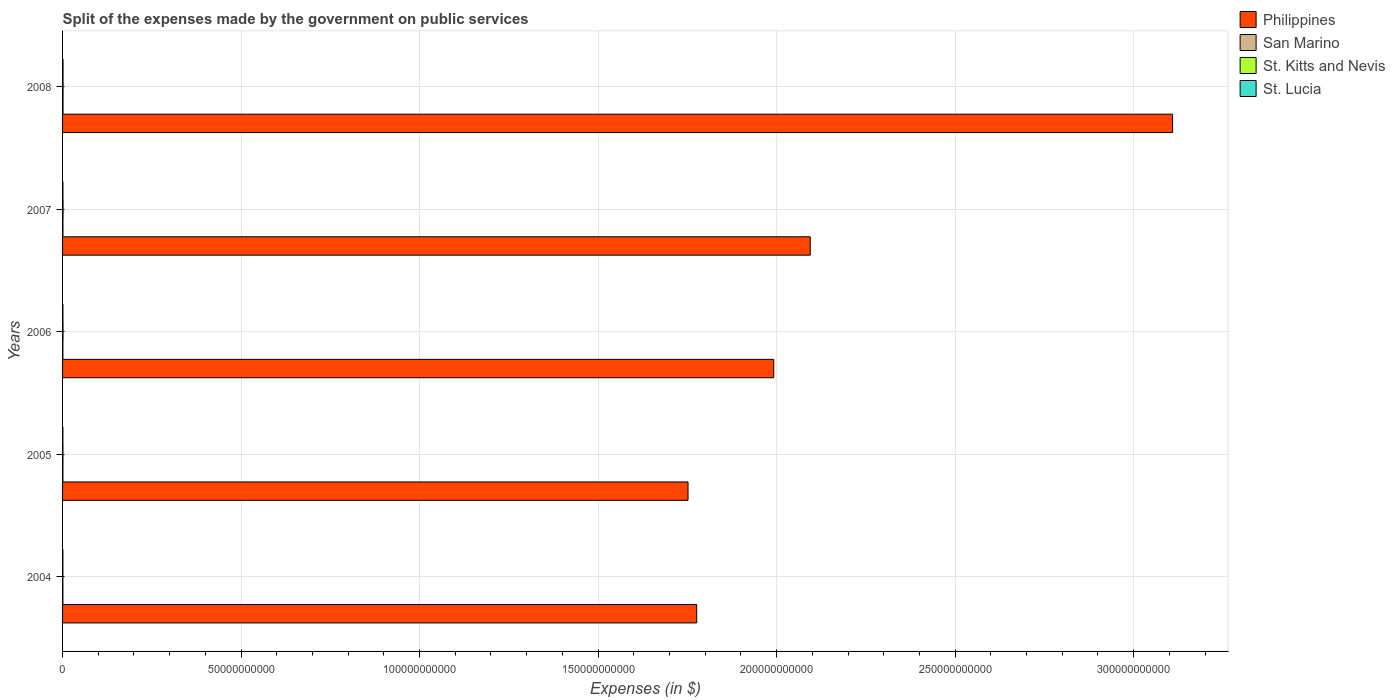How many different coloured bars are there?
Provide a short and direct response. 4. How many bars are there on the 5th tick from the top?
Offer a very short reply. 4. What is the label of the 2nd group of bars from the top?
Ensure brevity in your answer.  2007. What is the expenses made by the government on public services in St. Lucia in 2004?
Give a very brief answer. 9.55e+07. Across all years, what is the maximum expenses made by the government on public services in Philippines?
Ensure brevity in your answer.  3.11e+11. Across all years, what is the minimum expenses made by the government on public services in St. Kitts and Nevis?
Provide a succinct answer. 9.58e+07. What is the total expenses made by the government on public services in Philippines in the graph?
Your response must be concise. 1.07e+12. What is the difference between the expenses made by the government on public services in Philippines in 2004 and that in 2008?
Provide a short and direct response. -1.33e+11. What is the difference between the expenses made by the government on public services in Philippines in 2006 and the expenses made by the government on public services in San Marino in 2005?
Your answer should be very brief. 1.99e+11. What is the average expenses made by the government on public services in Philippines per year?
Your answer should be compact. 2.14e+11. In the year 2005, what is the difference between the expenses made by the government on public services in San Marino and expenses made by the government on public services in St. Lucia?
Keep it short and to the point. 7.29e+06. In how many years, is the expenses made by the government on public services in St. Lucia greater than 310000000000 $?
Keep it short and to the point. 0. What is the ratio of the expenses made by the government on public services in St. Kitts and Nevis in 2004 to that in 2008?
Keep it short and to the point. 0.7. Is the expenses made by the government on public services in St. Kitts and Nevis in 2006 less than that in 2008?
Your response must be concise. Yes. What is the difference between the highest and the second highest expenses made by the government on public services in Philippines?
Your answer should be very brief. 1.01e+11. What is the difference between the highest and the lowest expenses made by the government on public services in St. Lucia?
Offer a very short reply. 4.21e+07. In how many years, is the expenses made by the government on public services in St. Lucia greater than the average expenses made by the government on public services in St. Lucia taken over all years?
Keep it short and to the point. 1. Is the sum of the expenses made by the government on public services in San Marino in 2006 and 2008 greater than the maximum expenses made by the government on public services in Philippines across all years?
Give a very brief answer. No. Is it the case that in every year, the sum of the expenses made by the government on public services in St. Lucia and expenses made by the government on public services in Philippines is greater than the sum of expenses made by the government on public services in St. Kitts and Nevis and expenses made by the government on public services in San Marino?
Your response must be concise. Yes. What does the 3rd bar from the top in 2008 represents?
Offer a very short reply. San Marino. What does the 1st bar from the bottom in 2004 represents?
Your answer should be compact. Philippines. Are all the bars in the graph horizontal?
Keep it short and to the point. Yes. How many years are there in the graph?
Make the answer very short. 5. What is the difference between two consecutive major ticks on the X-axis?
Offer a very short reply. 5.00e+1. Are the values on the major ticks of X-axis written in scientific E-notation?
Offer a terse response. No. Does the graph contain grids?
Offer a very short reply. Yes. How many legend labels are there?
Provide a short and direct response. 4. How are the legend labels stacked?
Provide a succinct answer. Vertical. What is the title of the graph?
Provide a succinct answer. Split of the expenses made by the government on public services. What is the label or title of the X-axis?
Keep it short and to the point. Expenses (in $). What is the Expenses (in $) in Philippines in 2004?
Ensure brevity in your answer.  1.78e+11. What is the Expenses (in $) in San Marino in 2004?
Provide a short and direct response. 9.63e+07. What is the Expenses (in $) in St. Kitts and Nevis in 2004?
Give a very brief answer. 9.58e+07. What is the Expenses (in $) of St. Lucia in 2004?
Provide a short and direct response. 9.55e+07. What is the Expenses (in $) of Philippines in 2005?
Provide a short and direct response. 1.75e+11. What is the Expenses (in $) of San Marino in 2005?
Provide a short and direct response. 9.83e+07. What is the Expenses (in $) of St. Kitts and Nevis in 2005?
Ensure brevity in your answer.  1.15e+08. What is the Expenses (in $) in St. Lucia in 2005?
Keep it short and to the point. 9.10e+07. What is the Expenses (in $) of Philippines in 2006?
Provide a succinct answer. 1.99e+11. What is the Expenses (in $) in San Marino in 2006?
Your answer should be very brief. 9.27e+07. What is the Expenses (in $) in St. Kitts and Nevis in 2006?
Ensure brevity in your answer.  1.29e+08. What is the Expenses (in $) of St. Lucia in 2006?
Provide a short and direct response. 1.04e+08. What is the Expenses (in $) in Philippines in 2007?
Offer a very short reply. 2.09e+11. What is the Expenses (in $) in San Marino in 2007?
Offer a terse response. 1.09e+08. What is the Expenses (in $) of St. Kitts and Nevis in 2007?
Your response must be concise. 1.40e+08. What is the Expenses (in $) in St. Lucia in 2007?
Offer a terse response. 1.04e+08. What is the Expenses (in $) in Philippines in 2008?
Your answer should be very brief. 3.11e+11. What is the Expenses (in $) in San Marino in 2008?
Your answer should be very brief. 1.29e+08. What is the Expenses (in $) in St. Kitts and Nevis in 2008?
Provide a succinct answer. 1.37e+08. What is the Expenses (in $) of St. Lucia in 2008?
Ensure brevity in your answer.  1.33e+08. Across all years, what is the maximum Expenses (in $) of Philippines?
Provide a succinct answer. 3.11e+11. Across all years, what is the maximum Expenses (in $) in San Marino?
Make the answer very short. 1.29e+08. Across all years, what is the maximum Expenses (in $) of St. Kitts and Nevis?
Make the answer very short. 1.40e+08. Across all years, what is the maximum Expenses (in $) in St. Lucia?
Your answer should be compact. 1.33e+08. Across all years, what is the minimum Expenses (in $) of Philippines?
Your answer should be very brief. 1.75e+11. Across all years, what is the minimum Expenses (in $) of San Marino?
Your response must be concise. 9.27e+07. Across all years, what is the minimum Expenses (in $) of St. Kitts and Nevis?
Make the answer very short. 9.58e+07. Across all years, what is the minimum Expenses (in $) of St. Lucia?
Offer a very short reply. 9.10e+07. What is the total Expenses (in $) of Philippines in the graph?
Your answer should be compact. 1.07e+12. What is the total Expenses (in $) in San Marino in the graph?
Keep it short and to the point. 5.25e+08. What is the total Expenses (in $) of St. Kitts and Nevis in the graph?
Offer a very short reply. 6.18e+08. What is the total Expenses (in $) in St. Lucia in the graph?
Provide a short and direct response. 5.27e+08. What is the difference between the Expenses (in $) of Philippines in 2004 and that in 2005?
Provide a short and direct response. 2.43e+09. What is the difference between the Expenses (in $) in San Marino in 2004 and that in 2005?
Your answer should be very brief. -2.02e+06. What is the difference between the Expenses (in $) in St. Kitts and Nevis in 2004 and that in 2005?
Provide a short and direct response. -1.89e+07. What is the difference between the Expenses (in $) of St. Lucia in 2004 and that in 2005?
Provide a succinct answer. 4.50e+06. What is the difference between the Expenses (in $) of Philippines in 2004 and that in 2006?
Your answer should be compact. -2.16e+1. What is the difference between the Expenses (in $) in San Marino in 2004 and that in 2006?
Offer a very short reply. 3.57e+06. What is the difference between the Expenses (in $) in St. Kitts and Nevis in 2004 and that in 2006?
Offer a terse response. -3.36e+07. What is the difference between the Expenses (in $) of St. Lucia in 2004 and that in 2006?
Offer a very short reply. -8.80e+06. What is the difference between the Expenses (in $) of Philippines in 2004 and that in 2007?
Keep it short and to the point. -3.18e+1. What is the difference between the Expenses (in $) in San Marino in 2004 and that in 2007?
Give a very brief answer. -1.24e+07. What is the difference between the Expenses (in $) in St. Kitts and Nevis in 2004 and that in 2007?
Offer a very short reply. -4.46e+07. What is the difference between the Expenses (in $) of St. Lucia in 2004 and that in 2007?
Give a very brief answer. -8.00e+06. What is the difference between the Expenses (in $) in Philippines in 2004 and that in 2008?
Offer a terse response. -1.33e+11. What is the difference between the Expenses (in $) of San Marino in 2004 and that in 2008?
Provide a short and direct response. -3.28e+07. What is the difference between the Expenses (in $) of St. Kitts and Nevis in 2004 and that in 2008?
Your answer should be very brief. -4.14e+07. What is the difference between the Expenses (in $) of St. Lucia in 2004 and that in 2008?
Make the answer very short. -3.76e+07. What is the difference between the Expenses (in $) in Philippines in 2005 and that in 2006?
Your response must be concise. -2.40e+1. What is the difference between the Expenses (in $) in San Marino in 2005 and that in 2006?
Offer a very short reply. 5.58e+06. What is the difference between the Expenses (in $) of St. Kitts and Nevis in 2005 and that in 2006?
Keep it short and to the point. -1.47e+07. What is the difference between the Expenses (in $) in St. Lucia in 2005 and that in 2006?
Offer a very short reply. -1.33e+07. What is the difference between the Expenses (in $) of Philippines in 2005 and that in 2007?
Your response must be concise. -3.42e+1. What is the difference between the Expenses (in $) of San Marino in 2005 and that in 2007?
Offer a very short reply. -1.04e+07. What is the difference between the Expenses (in $) of St. Kitts and Nevis in 2005 and that in 2007?
Provide a succinct answer. -2.57e+07. What is the difference between the Expenses (in $) of St. Lucia in 2005 and that in 2007?
Offer a very short reply. -1.25e+07. What is the difference between the Expenses (in $) in Philippines in 2005 and that in 2008?
Provide a succinct answer. -1.36e+11. What is the difference between the Expenses (in $) of San Marino in 2005 and that in 2008?
Provide a short and direct response. -3.08e+07. What is the difference between the Expenses (in $) in St. Kitts and Nevis in 2005 and that in 2008?
Your answer should be very brief. -2.25e+07. What is the difference between the Expenses (in $) in St. Lucia in 2005 and that in 2008?
Your response must be concise. -4.21e+07. What is the difference between the Expenses (in $) in Philippines in 2006 and that in 2007?
Ensure brevity in your answer.  -1.02e+1. What is the difference between the Expenses (in $) in San Marino in 2006 and that in 2007?
Provide a succinct answer. -1.60e+07. What is the difference between the Expenses (in $) in St. Kitts and Nevis in 2006 and that in 2007?
Provide a short and direct response. -1.10e+07. What is the difference between the Expenses (in $) of Philippines in 2006 and that in 2008?
Ensure brevity in your answer.  -1.12e+11. What is the difference between the Expenses (in $) of San Marino in 2006 and that in 2008?
Give a very brief answer. -3.64e+07. What is the difference between the Expenses (in $) of St. Kitts and Nevis in 2006 and that in 2008?
Keep it short and to the point. -7.80e+06. What is the difference between the Expenses (in $) of St. Lucia in 2006 and that in 2008?
Your response must be concise. -2.88e+07. What is the difference between the Expenses (in $) in Philippines in 2007 and that in 2008?
Make the answer very short. -1.01e+11. What is the difference between the Expenses (in $) in San Marino in 2007 and that in 2008?
Provide a succinct answer. -2.04e+07. What is the difference between the Expenses (in $) in St. Kitts and Nevis in 2007 and that in 2008?
Provide a succinct answer. 3.20e+06. What is the difference between the Expenses (in $) in St. Lucia in 2007 and that in 2008?
Your answer should be compact. -2.96e+07. What is the difference between the Expenses (in $) of Philippines in 2004 and the Expenses (in $) of San Marino in 2005?
Keep it short and to the point. 1.78e+11. What is the difference between the Expenses (in $) of Philippines in 2004 and the Expenses (in $) of St. Kitts and Nevis in 2005?
Your response must be concise. 1.78e+11. What is the difference between the Expenses (in $) of Philippines in 2004 and the Expenses (in $) of St. Lucia in 2005?
Offer a terse response. 1.78e+11. What is the difference between the Expenses (in $) of San Marino in 2004 and the Expenses (in $) of St. Kitts and Nevis in 2005?
Offer a very short reply. -1.84e+07. What is the difference between the Expenses (in $) in San Marino in 2004 and the Expenses (in $) in St. Lucia in 2005?
Keep it short and to the point. 5.28e+06. What is the difference between the Expenses (in $) of St. Kitts and Nevis in 2004 and the Expenses (in $) of St. Lucia in 2005?
Your answer should be very brief. 4.80e+06. What is the difference between the Expenses (in $) in Philippines in 2004 and the Expenses (in $) in San Marino in 2006?
Your response must be concise. 1.78e+11. What is the difference between the Expenses (in $) in Philippines in 2004 and the Expenses (in $) in St. Kitts and Nevis in 2006?
Your answer should be compact. 1.77e+11. What is the difference between the Expenses (in $) in Philippines in 2004 and the Expenses (in $) in St. Lucia in 2006?
Give a very brief answer. 1.78e+11. What is the difference between the Expenses (in $) of San Marino in 2004 and the Expenses (in $) of St. Kitts and Nevis in 2006?
Provide a succinct answer. -3.31e+07. What is the difference between the Expenses (in $) of San Marino in 2004 and the Expenses (in $) of St. Lucia in 2006?
Your response must be concise. -8.02e+06. What is the difference between the Expenses (in $) of St. Kitts and Nevis in 2004 and the Expenses (in $) of St. Lucia in 2006?
Ensure brevity in your answer.  -8.50e+06. What is the difference between the Expenses (in $) in Philippines in 2004 and the Expenses (in $) in San Marino in 2007?
Offer a very short reply. 1.78e+11. What is the difference between the Expenses (in $) of Philippines in 2004 and the Expenses (in $) of St. Kitts and Nevis in 2007?
Keep it short and to the point. 1.77e+11. What is the difference between the Expenses (in $) of Philippines in 2004 and the Expenses (in $) of St. Lucia in 2007?
Ensure brevity in your answer.  1.78e+11. What is the difference between the Expenses (in $) in San Marino in 2004 and the Expenses (in $) in St. Kitts and Nevis in 2007?
Offer a very short reply. -4.41e+07. What is the difference between the Expenses (in $) of San Marino in 2004 and the Expenses (in $) of St. Lucia in 2007?
Provide a short and direct response. -7.22e+06. What is the difference between the Expenses (in $) of St. Kitts and Nevis in 2004 and the Expenses (in $) of St. Lucia in 2007?
Offer a very short reply. -7.70e+06. What is the difference between the Expenses (in $) of Philippines in 2004 and the Expenses (in $) of San Marino in 2008?
Your answer should be compact. 1.77e+11. What is the difference between the Expenses (in $) of Philippines in 2004 and the Expenses (in $) of St. Kitts and Nevis in 2008?
Offer a very short reply. 1.77e+11. What is the difference between the Expenses (in $) of Philippines in 2004 and the Expenses (in $) of St. Lucia in 2008?
Keep it short and to the point. 1.77e+11. What is the difference between the Expenses (in $) of San Marino in 2004 and the Expenses (in $) of St. Kitts and Nevis in 2008?
Keep it short and to the point. -4.09e+07. What is the difference between the Expenses (in $) of San Marino in 2004 and the Expenses (in $) of St. Lucia in 2008?
Your answer should be compact. -3.68e+07. What is the difference between the Expenses (in $) in St. Kitts and Nevis in 2004 and the Expenses (in $) in St. Lucia in 2008?
Ensure brevity in your answer.  -3.73e+07. What is the difference between the Expenses (in $) in Philippines in 2005 and the Expenses (in $) in San Marino in 2006?
Provide a short and direct response. 1.75e+11. What is the difference between the Expenses (in $) in Philippines in 2005 and the Expenses (in $) in St. Kitts and Nevis in 2006?
Your response must be concise. 1.75e+11. What is the difference between the Expenses (in $) of Philippines in 2005 and the Expenses (in $) of St. Lucia in 2006?
Give a very brief answer. 1.75e+11. What is the difference between the Expenses (in $) of San Marino in 2005 and the Expenses (in $) of St. Kitts and Nevis in 2006?
Keep it short and to the point. -3.11e+07. What is the difference between the Expenses (in $) in San Marino in 2005 and the Expenses (in $) in St. Lucia in 2006?
Provide a succinct answer. -6.01e+06. What is the difference between the Expenses (in $) of St. Kitts and Nevis in 2005 and the Expenses (in $) of St. Lucia in 2006?
Offer a terse response. 1.04e+07. What is the difference between the Expenses (in $) in Philippines in 2005 and the Expenses (in $) in San Marino in 2007?
Your answer should be very brief. 1.75e+11. What is the difference between the Expenses (in $) in Philippines in 2005 and the Expenses (in $) in St. Kitts and Nevis in 2007?
Provide a succinct answer. 1.75e+11. What is the difference between the Expenses (in $) of Philippines in 2005 and the Expenses (in $) of St. Lucia in 2007?
Make the answer very short. 1.75e+11. What is the difference between the Expenses (in $) in San Marino in 2005 and the Expenses (in $) in St. Kitts and Nevis in 2007?
Make the answer very short. -4.21e+07. What is the difference between the Expenses (in $) of San Marino in 2005 and the Expenses (in $) of St. Lucia in 2007?
Your response must be concise. -5.21e+06. What is the difference between the Expenses (in $) of St. Kitts and Nevis in 2005 and the Expenses (in $) of St. Lucia in 2007?
Provide a short and direct response. 1.12e+07. What is the difference between the Expenses (in $) in Philippines in 2005 and the Expenses (in $) in San Marino in 2008?
Provide a succinct answer. 1.75e+11. What is the difference between the Expenses (in $) in Philippines in 2005 and the Expenses (in $) in St. Kitts and Nevis in 2008?
Keep it short and to the point. 1.75e+11. What is the difference between the Expenses (in $) of Philippines in 2005 and the Expenses (in $) of St. Lucia in 2008?
Your answer should be very brief. 1.75e+11. What is the difference between the Expenses (in $) of San Marino in 2005 and the Expenses (in $) of St. Kitts and Nevis in 2008?
Keep it short and to the point. -3.89e+07. What is the difference between the Expenses (in $) in San Marino in 2005 and the Expenses (in $) in St. Lucia in 2008?
Ensure brevity in your answer.  -3.48e+07. What is the difference between the Expenses (in $) of St. Kitts and Nevis in 2005 and the Expenses (in $) of St. Lucia in 2008?
Your response must be concise. -1.84e+07. What is the difference between the Expenses (in $) of Philippines in 2006 and the Expenses (in $) of San Marino in 2007?
Make the answer very short. 1.99e+11. What is the difference between the Expenses (in $) of Philippines in 2006 and the Expenses (in $) of St. Kitts and Nevis in 2007?
Keep it short and to the point. 1.99e+11. What is the difference between the Expenses (in $) of Philippines in 2006 and the Expenses (in $) of St. Lucia in 2007?
Your response must be concise. 1.99e+11. What is the difference between the Expenses (in $) of San Marino in 2006 and the Expenses (in $) of St. Kitts and Nevis in 2007?
Offer a terse response. -4.77e+07. What is the difference between the Expenses (in $) in San Marino in 2006 and the Expenses (in $) in St. Lucia in 2007?
Ensure brevity in your answer.  -1.08e+07. What is the difference between the Expenses (in $) of St. Kitts and Nevis in 2006 and the Expenses (in $) of St. Lucia in 2007?
Offer a terse response. 2.59e+07. What is the difference between the Expenses (in $) of Philippines in 2006 and the Expenses (in $) of San Marino in 2008?
Give a very brief answer. 1.99e+11. What is the difference between the Expenses (in $) of Philippines in 2006 and the Expenses (in $) of St. Kitts and Nevis in 2008?
Make the answer very short. 1.99e+11. What is the difference between the Expenses (in $) of Philippines in 2006 and the Expenses (in $) of St. Lucia in 2008?
Your answer should be compact. 1.99e+11. What is the difference between the Expenses (in $) in San Marino in 2006 and the Expenses (in $) in St. Kitts and Nevis in 2008?
Offer a very short reply. -4.45e+07. What is the difference between the Expenses (in $) of San Marino in 2006 and the Expenses (in $) of St. Lucia in 2008?
Provide a short and direct response. -4.04e+07. What is the difference between the Expenses (in $) of St. Kitts and Nevis in 2006 and the Expenses (in $) of St. Lucia in 2008?
Your answer should be compact. -3.70e+06. What is the difference between the Expenses (in $) of Philippines in 2007 and the Expenses (in $) of San Marino in 2008?
Give a very brief answer. 2.09e+11. What is the difference between the Expenses (in $) in Philippines in 2007 and the Expenses (in $) in St. Kitts and Nevis in 2008?
Offer a very short reply. 2.09e+11. What is the difference between the Expenses (in $) in Philippines in 2007 and the Expenses (in $) in St. Lucia in 2008?
Offer a very short reply. 2.09e+11. What is the difference between the Expenses (in $) in San Marino in 2007 and the Expenses (in $) in St. Kitts and Nevis in 2008?
Ensure brevity in your answer.  -2.85e+07. What is the difference between the Expenses (in $) of San Marino in 2007 and the Expenses (in $) of St. Lucia in 2008?
Offer a terse response. -2.44e+07. What is the difference between the Expenses (in $) in St. Kitts and Nevis in 2007 and the Expenses (in $) in St. Lucia in 2008?
Offer a very short reply. 7.30e+06. What is the average Expenses (in $) of Philippines per year?
Your answer should be compact. 2.14e+11. What is the average Expenses (in $) in San Marino per year?
Your answer should be compact. 1.05e+08. What is the average Expenses (in $) of St. Kitts and Nevis per year?
Your answer should be compact. 1.24e+08. What is the average Expenses (in $) of St. Lucia per year?
Keep it short and to the point. 1.05e+08. In the year 2004, what is the difference between the Expenses (in $) in Philippines and Expenses (in $) in San Marino?
Make the answer very short. 1.78e+11. In the year 2004, what is the difference between the Expenses (in $) in Philippines and Expenses (in $) in St. Kitts and Nevis?
Make the answer very short. 1.78e+11. In the year 2004, what is the difference between the Expenses (in $) of Philippines and Expenses (in $) of St. Lucia?
Your response must be concise. 1.78e+11. In the year 2004, what is the difference between the Expenses (in $) in San Marino and Expenses (in $) in St. Kitts and Nevis?
Ensure brevity in your answer.  4.77e+05. In the year 2004, what is the difference between the Expenses (in $) in San Marino and Expenses (in $) in St. Lucia?
Your answer should be compact. 7.77e+05. In the year 2005, what is the difference between the Expenses (in $) of Philippines and Expenses (in $) of San Marino?
Your answer should be compact. 1.75e+11. In the year 2005, what is the difference between the Expenses (in $) in Philippines and Expenses (in $) in St. Kitts and Nevis?
Your response must be concise. 1.75e+11. In the year 2005, what is the difference between the Expenses (in $) of Philippines and Expenses (in $) of St. Lucia?
Your response must be concise. 1.75e+11. In the year 2005, what is the difference between the Expenses (in $) in San Marino and Expenses (in $) in St. Kitts and Nevis?
Give a very brief answer. -1.64e+07. In the year 2005, what is the difference between the Expenses (in $) in San Marino and Expenses (in $) in St. Lucia?
Offer a very short reply. 7.29e+06. In the year 2005, what is the difference between the Expenses (in $) of St. Kitts and Nevis and Expenses (in $) of St. Lucia?
Provide a succinct answer. 2.37e+07. In the year 2006, what is the difference between the Expenses (in $) in Philippines and Expenses (in $) in San Marino?
Make the answer very short. 1.99e+11. In the year 2006, what is the difference between the Expenses (in $) in Philippines and Expenses (in $) in St. Kitts and Nevis?
Offer a very short reply. 1.99e+11. In the year 2006, what is the difference between the Expenses (in $) in Philippines and Expenses (in $) in St. Lucia?
Give a very brief answer. 1.99e+11. In the year 2006, what is the difference between the Expenses (in $) of San Marino and Expenses (in $) of St. Kitts and Nevis?
Your answer should be compact. -3.67e+07. In the year 2006, what is the difference between the Expenses (in $) of San Marino and Expenses (in $) of St. Lucia?
Provide a succinct answer. -1.16e+07. In the year 2006, what is the difference between the Expenses (in $) of St. Kitts and Nevis and Expenses (in $) of St. Lucia?
Keep it short and to the point. 2.51e+07. In the year 2007, what is the difference between the Expenses (in $) in Philippines and Expenses (in $) in San Marino?
Offer a terse response. 2.09e+11. In the year 2007, what is the difference between the Expenses (in $) in Philippines and Expenses (in $) in St. Kitts and Nevis?
Your answer should be compact. 2.09e+11. In the year 2007, what is the difference between the Expenses (in $) of Philippines and Expenses (in $) of St. Lucia?
Keep it short and to the point. 2.09e+11. In the year 2007, what is the difference between the Expenses (in $) of San Marino and Expenses (in $) of St. Kitts and Nevis?
Provide a succinct answer. -3.17e+07. In the year 2007, what is the difference between the Expenses (in $) of San Marino and Expenses (in $) of St. Lucia?
Offer a terse response. 5.22e+06. In the year 2007, what is the difference between the Expenses (in $) of St. Kitts and Nevis and Expenses (in $) of St. Lucia?
Your answer should be compact. 3.69e+07. In the year 2008, what is the difference between the Expenses (in $) in Philippines and Expenses (in $) in San Marino?
Keep it short and to the point. 3.11e+11. In the year 2008, what is the difference between the Expenses (in $) of Philippines and Expenses (in $) of St. Kitts and Nevis?
Your answer should be very brief. 3.11e+11. In the year 2008, what is the difference between the Expenses (in $) of Philippines and Expenses (in $) of St. Lucia?
Make the answer very short. 3.11e+11. In the year 2008, what is the difference between the Expenses (in $) in San Marino and Expenses (in $) in St. Kitts and Nevis?
Make the answer very short. -8.11e+06. In the year 2008, what is the difference between the Expenses (in $) of San Marino and Expenses (in $) of St. Lucia?
Provide a succinct answer. -4.01e+06. In the year 2008, what is the difference between the Expenses (in $) in St. Kitts and Nevis and Expenses (in $) in St. Lucia?
Give a very brief answer. 4.10e+06. What is the ratio of the Expenses (in $) in Philippines in 2004 to that in 2005?
Your answer should be very brief. 1.01. What is the ratio of the Expenses (in $) in San Marino in 2004 to that in 2005?
Keep it short and to the point. 0.98. What is the ratio of the Expenses (in $) in St. Kitts and Nevis in 2004 to that in 2005?
Provide a succinct answer. 0.84. What is the ratio of the Expenses (in $) in St. Lucia in 2004 to that in 2005?
Your response must be concise. 1.05. What is the ratio of the Expenses (in $) in Philippines in 2004 to that in 2006?
Ensure brevity in your answer.  0.89. What is the ratio of the Expenses (in $) of San Marino in 2004 to that in 2006?
Your answer should be very brief. 1.04. What is the ratio of the Expenses (in $) in St. Kitts and Nevis in 2004 to that in 2006?
Provide a short and direct response. 0.74. What is the ratio of the Expenses (in $) in St. Lucia in 2004 to that in 2006?
Your response must be concise. 0.92. What is the ratio of the Expenses (in $) of Philippines in 2004 to that in 2007?
Your answer should be compact. 0.85. What is the ratio of the Expenses (in $) of San Marino in 2004 to that in 2007?
Provide a succinct answer. 0.89. What is the ratio of the Expenses (in $) of St. Kitts and Nevis in 2004 to that in 2007?
Give a very brief answer. 0.68. What is the ratio of the Expenses (in $) in St. Lucia in 2004 to that in 2007?
Offer a terse response. 0.92. What is the ratio of the Expenses (in $) in Philippines in 2004 to that in 2008?
Offer a terse response. 0.57. What is the ratio of the Expenses (in $) of San Marino in 2004 to that in 2008?
Give a very brief answer. 0.75. What is the ratio of the Expenses (in $) in St. Kitts and Nevis in 2004 to that in 2008?
Offer a very short reply. 0.7. What is the ratio of the Expenses (in $) in St. Lucia in 2004 to that in 2008?
Your answer should be very brief. 0.72. What is the ratio of the Expenses (in $) of Philippines in 2005 to that in 2006?
Provide a succinct answer. 0.88. What is the ratio of the Expenses (in $) of San Marino in 2005 to that in 2006?
Give a very brief answer. 1.06. What is the ratio of the Expenses (in $) of St. Kitts and Nevis in 2005 to that in 2006?
Ensure brevity in your answer.  0.89. What is the ratio of the Expenses (in $) in St. Lucia in 2005 to that in 2006?
Ensure brevity in your answer.  0.87. What is the ratio of the Expenses (in $) of Philippines in 2005 to that in 2007?
Your answer should be very brief. 0.84. What is the ratio of the Expenses (in $) of San Marino in 2005 to that in 2007?
Your answer should be very brief. 0.9. What is the ratio of the Expenses (in $) of St. Kitts and Nevis in 2005 to that in 2007?
Your answer should be very brief. 0.82. What is the ratio of the Expenses (in $) in St. Lucia in 2005 to that in 2007?
Offer a very short reply. 0.88. What is the ratio of the Expenses (in $) of Philippines in 2005 to that in 2008?
Provide a succinct answer. 0.56. What is the ratio of the Expenses (in $) of San Marino in 2005 to that in 2008?
Ensure brevity in your answer.  0.76. What is the ratio of the Expenses (in $) of St. Kitts and Nevis in 2005 to that in 2008?
Provide a short and direct response. 0.84. What is the ratio of the Expenses (in $) of St. Lucia in 2005 to that in 2008?
Ensure brevity in your answer.  0.68. What is the ratio of the Expenses (in $) in Philippines in 2006 to that in 2007?
Provide a succinct answer. 0.95. What is the ratio of the Expenses (in $) of San Marino in 2006 to that in 2007?
Ensure brevity in your answer.  0.85. What is the ratio of the Expenses (in $) of St. Kitts and Nevis in 2006 to that in 2007?
Your answer should be compact. 0.92. What is the ratio of the Expenses (in $) of St. Lucia in 2006 to that in 2007?
Make the answer very short. 1.01. What is the ratio of the Expenses (in $) of Philippines in 2006 to that in 2008?
Offer a very short reply. 0.64. What is the ratio of the Expenses (in $) of San Marino in 2006 to that in 2008?
Provide a short and direct response. 0.72. What is the ratio of the Expenses (in $) in St. Kitts and Nevis in 2006 to that in 2008?
Your answer should be very brief. 0.94. What is the ratio of the Expenses (in $) of St. Lucia in 2006 to that in 2008?
Your answer should be compact. 0.78. What is the ratio of the Expenses (in $) in Philippines in 2007 to that in 2008?
Offer a very short reply. 0.67. What is the ratio of the Expenses (in $) in San Marino in 2007 to that in 2008?
Offer a very short reply. 0.84. What is the ratio of the Expenses (in $) in St. Kitts and Nevis in 2007 to that in 2008?
Make the answer very short. 1.02. What is the ratio of the Expenses (in $) of St. Lucia in 2007 to that in 2008?
Your answer should be very brief. 0.78. What is the difference between the highest and the second highest Expenses (in $) of Philippines?
Ensure brevity in your answer.  1.01e+11. What is the difference between the highest and the second highest Expenses (in $) in San Marino?
Make the answer very short. 2.04e+07. What is the difference between the highest and the second highest Expenses (in $) in St. Kitts and Nevis?
Your answer should be compact. 3.20e+06. What is the difference between the highest and the second highest Expenses (in $) in St. Lucia?
Make the answer very short. 2.88e+07. What is the difference between the highest and the lowest Expenses (in $) in Philippines?
Your answer should be compact. 1.36e+11. What is the difference between the highest and the lowest Expenses (in $) in San Marino?
Ensure brevity in your answer.  3.64e+07. What is the difference between the highest and the lowest Expenses (in $) of St. Kitts and Nevis?
Provide a succinct answer. 4.46e+07. What is the difference between the highest and the lowest Expenses (in $) in St. Lucia?
Your answer should be compact. 4.21e+07. 